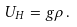Convert formula to latex. <formula><loc_0><loc_0><loc_500><loc_500>U _ { H } = g \rho \, .</formula> 